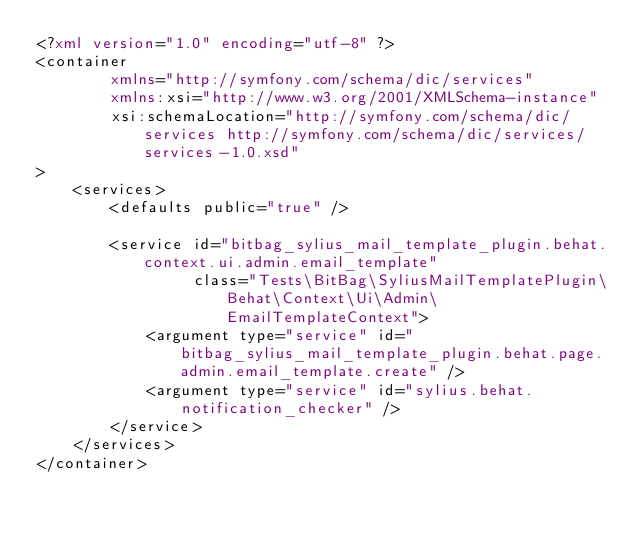<code> <loc_0><loc_0><loc_500><loc_500><_XML_><?xml version="1.0" encoding="utf-8" ?>
<container
        xmlns="http://symfony.com/schema/dic/services"
        xmlns:xsi="http://www.w3.org/2001/XMLSchema-instance"
        xsi:schemaLocation="http://symfony.com/schema/dic/services http://symfony.com/schema/dic/services/services-1.0.xsd"
>
    <services>
        <defaults public="true" />

        <service id="bitbag_sylius_mail_template_plugin.behat.context.ui.admin.email_template"
                 class="Tests\BitBag\SyliusMailTemplatePlugin\Behat\Context\Ui\Admin\EmailTemplateContext">
            <argument type="service" id="bitbag_sylius_mail_template_plugin.behat.page.admin.email_template.create" />
            <argument type="service" id="sylius.behat.notification_checker" />
        </service>
    </services>
</container>
</code> 